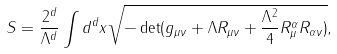<formula> <loc_0><loc_0><loc_500><loc_500>S = \frac { 2 ^ { d } } { \Lambda ^ { d } } \int d ^ { d } x \sqrt { - \det ( g _ { \mu \nu } + \Lambda R _ { \mu \nu } + \frac { \Lambda ^ { 2 } } { 4 } R _ { \mu } ^ { \alpha } R _ { \alpha \nu } ) } ,</formula> 